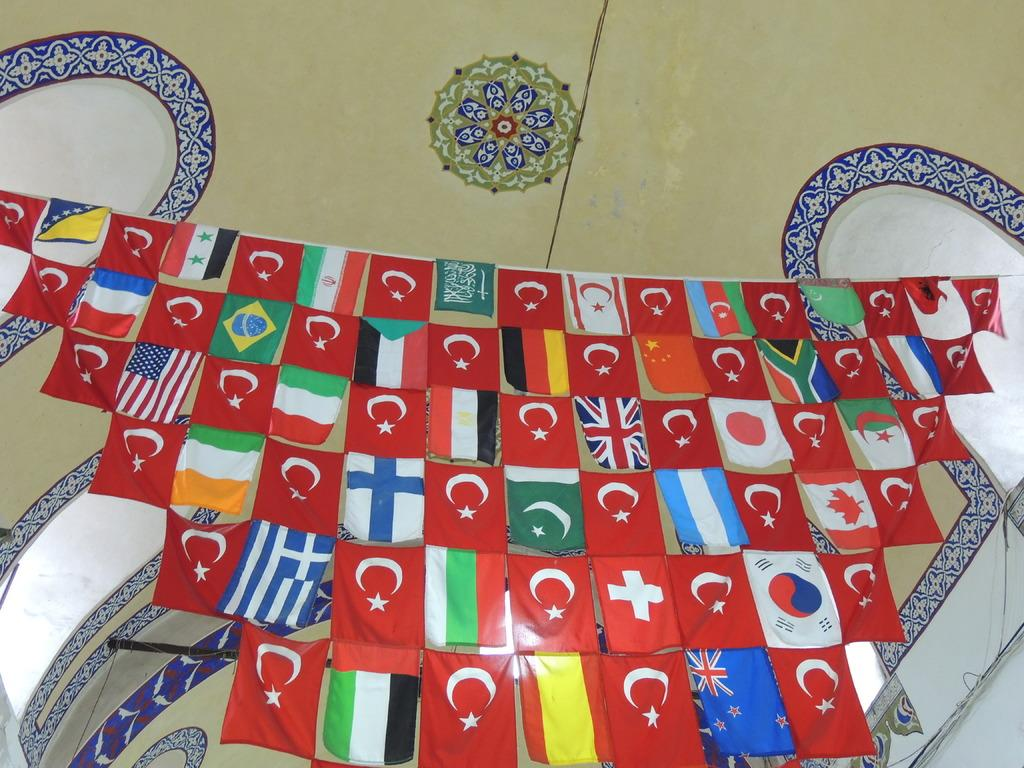What can be seen hanging from a rope in the image? There are flags hanging from a rope in the image. What type of artwork is present on the wall in the image? There is a wall painting in the image. Can you see a goat walking down the alley in the image? There is no goat or alley present in the image. What type of knife is being used to create the wall painting in the image? There is no knife present in the image, as the wall painting is already completed. 